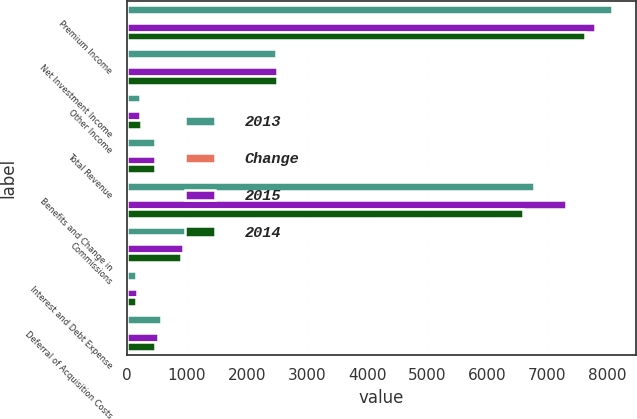Convert chart to OTSL. <chart><loc_0><loc_0><loc_500><loc_500><stacked_bar_chart><ecel><fcel>Premium Income<fcel>Net Investment Income<fcel>Other Income<fcel>Total Revenue<fcel>Benefits and Change in<fcel>Commissions<fcel>Interest and Debt Expense<fcel>Deferral of Acquisition Costs<nl><fcel>2013<fcel>8082.4<fcel>2481.2<fcel>211.5<fcel>466.8<fcel>6782.8<fcel>996.3<fcel>152.8<fcel>569.7<nl><fcel>Change<fcel>3.7<fcel>0.4<fcel>3.4<fcel>2<fcel>7.2<fcel>6.5<fcel>8.8<fcel>8.7<nl><fcel>2015<fcel>7797.2<fcel>2492.2<fcel>219<fcel>466.8<fcel>7310.8<fcel>935.3<fcel>167.5<fcel>524<nl><fcel>2014<fcel>7624.7<fcel>2506.9<fcel>230.2<fcel>466.8<fcel>6595.7<fcel>909.5<fcel>149.4<fcel>466.8<nl></chart> 